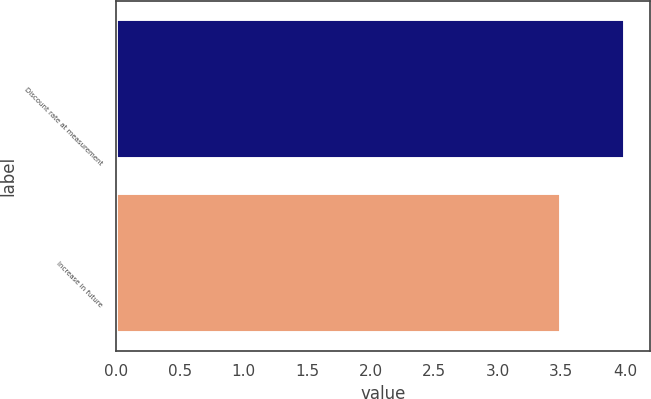<chart> <loc_0><loc_0><loc_500><loc_500><bar_chart><fcel>Discount rate at measurement<fcel>Increase in future<nl><fcel>4<fcel>3.5<nl></chart> 